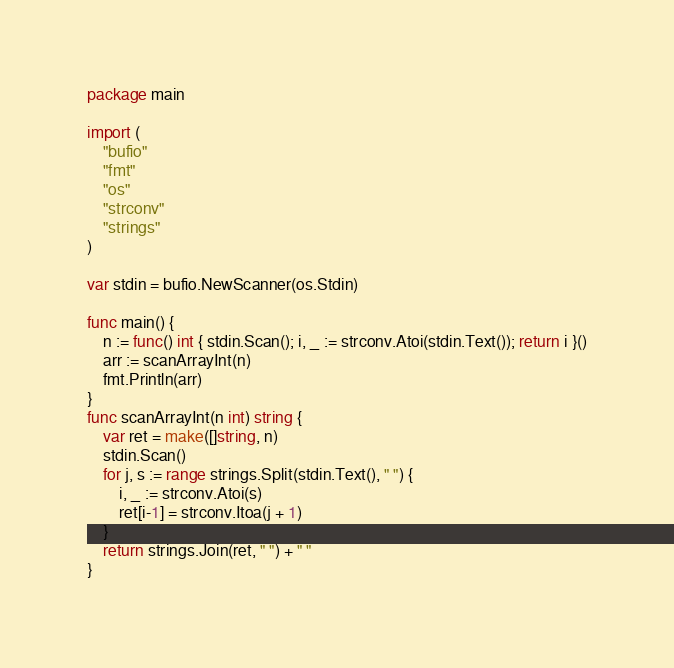<code> <loc_0><loc_0><loc_500><loc_500><_Go_>package main

import (
	"bufio"
	"fmt"
	"os"
	"strconv"
	"strings"
)

var stdin = bufio.NewScanner(os.Stdin)

func main() {
	n := func() int { stdin.Scan(); i, _ := strconv.Atoi(stdin.Text()); return i }()
	arr := scanArrayInt(n)
	fmt.Println(arr)
}
func scanArrayInt(n int) string {
	var ret = make([]string, n)
	stdin.Scan()
	for j, s := range strings.Split(stdin.Text(), " ") {
		i, _ := strconv.Atoi(s)
		ret[i-1] = strconv.Itoa(j + 1)
	}
	return strings.Join(ret, " ") + " "
}</code> 